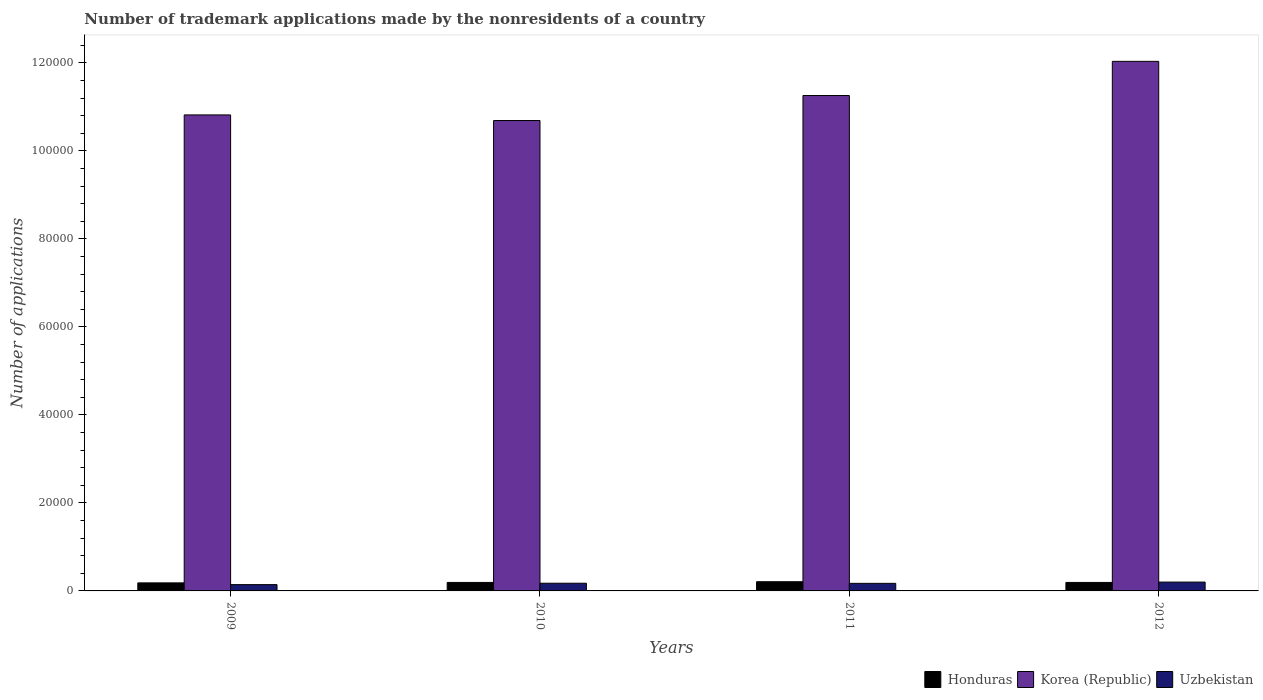Are the number of bars per tick equal to the number of legend labels?
Make the answer very short. Yes. How many bars are there on the 3rd tick from the left?
Provide a short and direct response. 3. How many bars are there on the 2nd tick from the right?
Provide a succinct answer. 3. What is the number of trademark applications made by the nonresidents in Uzbekistan in 2009?
Your answer should be compact. 1431. Across all years, what is the maximum number of trademark applications made by the nonresidents in Honduras?
Your response must be concise. 2089. Across all years, what is the minimum number of trademark applications made by the nonresidents in Korea (Republic)?
Your response must be concise. 1.07e+05. What is the total number of trademark applications made by the nonresidents in Uzbekistan in the graph?
Offer a terse response. 6908. What is the difference between the number of trademark applications made by the nonresidents in Uzbekistan in 2010 and the number of trademark applications made by the nonresidents in Honduras in 2009?
Offer a very short reply. -78. What is the average number of trademark applications made by the nonresidents in Honduras per year?
Your answer should be compact. 1944. In the year 2010, what is the difference between the number of trademark applications made by the nonresidents in Honduras and number of trademark applications made by the nonresidents in Uzbekistan?
Provide a succinct answer. 180. In how many years, is the number of trademark applications made by the nonresidents in Korea (Republic) greater than 60000?
Your response must be concise. 4. What is the ratio of the number of trademark applications made by the nonresidents in Korea (Republic) in 2009 to that in 2011?
Provide a short and direct response. 0.96. Is the number of trademark applications made by the nonresidents in Honduras in 2009 less than that in 2010?
Offer a terse response. Yes. What is the difference between the highest and the second highest number of trademark applications made by the nonresidents in Uzbekistan?
Give a very brief answer. 257. What is the difference between the highest and the lowest number of trademark applications made by the nonresidents in Uzbekistan?
Offer a very short reply. 576. In how many years, is the number of trademark applications made by the nonresidents in Honduras greater than the average number of trademark applications made by the nonresidents in Honduras taken over all years?
Make the answer very short. 1. What does the 3rd bar from the left in 2010 represents?
Your response must be concise. Uzbekistan. What does the 1st bar from the right in 2009 represents?
Keep it short and to the point. Uzbekistan. Is it the case that in every year, the sum of the number of trademark applications made by the nonresidents in Uzbekistan and number of trademark applications made by the nonresidents in Honduras is greater than the number of trademark applications made by the nonresidents in Korea (Republic)?
Offer a terse response. No. How many bars are there?
Provide a succinct answer. 12. How many years are there in the graph?
Your answer should be compact. 4. What is the difference between two consecutive major ticks on the Y-axis?
Give a very brief answer. 2.00e+04. Are the values on the major ticks of Y-axis written in scientific E-notation?
Your response must be concise. No. Does the graph contain any zero values?
Ensure brevity in your answer.  No. How many legend labels are there?
Offer a terse response. 3. How are the legend labels stacked?
Keep it short and to the point. Horizontal. What is the title of the graph?
Your answer should be very brief. Number of trademark applications made by the nonresidents of a country. Does "Oman" appear as one of the legend labels in the graph?
Offer a terse response. No. What is the label or title of the Y-axis?
Your answer should be very brief. Number of applications. What is the Number of applications of Honduras in 2009?
Make the answer very short. 1828. What is the Number of applications in Korea (Republic) in 2009?
Give a very brief answer. 1.08e+05. What is the Number of applications in Uzbekistan in 2009?
Provide a succinct answer. 1431. What is the Number of applications of Honduras in 2010?
Your answer should be compact. 1930. What is the Number of applications in Korea (Republic) in 2010?
Make the answer very short. 1.07e+05. What is the Number of applications in Uzbekistan in 2010?
Make the answer very short. 1750. What is the Number of applications of Honduras in 2011?
Make the answer very short. 2089. What is the Number of applications of Korea (Republic) in 2011?
Keep it short and to the point. 1.13e+05. What is the Number of applications in Uzbekistan in 2011?
Your answer should be compact. 1720. What is the Number of applications in Honduras in 2012?
Provide a succinct answer. 1929. What is the Number of applications in Korea (Republic) in 2012?
Provide a succinct answer. 1.20e+05. What is the Number of applications of Uzbekistan in 2012?
Keep it short and to the point. 2007. Across all years, what is the maximum Number of applications of Honduras?
Give a very brief answer. 2089. Across all years, what is the maximum Number of applications in Korea (Republic)?
Offer a very short reply. 1.20e+05. Across all years, what is the maximum Number of applications in Uzbekistan?
Offer a terse response. 2007. Across all years, what is the minimum Number of applications of Honduras?
Your response must be concise. 1828. Across all years, what is the minimum Number of applications of Korea (Republic)?
Make the answer very short. 1.07e+05. Across all years, what is the minimum Number of applications in Uzbekistan?
Provide a succinct answer. 1431. What is the total Number of applications in Honduras in the graph?
Give a very brief answer. 7776. What is the total Number of applications of Korea (Republic) in the graph?
Provide a succinct answer. 4.48e+05. What is the total Number of applications of Uzbekistan in the graph?
Ensure brevity in your answer.  6908. What is the difference between the Number of applications of Honduras in 2009 and that in 2010?
Ensure brevity in your answer.  -102. What is the difference between the Number of applications in Korea (Republic) in 2009 and that in 2010?
Your response must be concise. 1274. What is the difference between the Number of applications of Uzbekistan in 2009 and that in 2010?
Ensure brevity in your answer.  -319. What is the difference between the Number of applications of Honduras in 2009 and that in 2011?
Make the answer very short. -261. What is the difference between the Number of applications of Korea (Republic) in 2009 and that in 2011?
Provide a short and direct response. -4406. What is the difference between the Number of applications of Uzbekistan in 2009 and that in 2011?
Keep it short and to the point. -289. What is the difference between the Number of applications in Honduras in 2009 and that in 2012?
Offer a very short reply. -101. What is the difference between the Number of applications of Korea (Republic) in 2009 and that in 2012?
Make the answer very short. -1.22e+04. What is the difference between the Number of applications of Uzbekistan in 2009 and that in 2012?
Your answer should be compact. -576. What is the difference between the Number of applications in Honduras in 2010 and that in 2011?
Your answer should be compact. -159. What is the difference between the Number of applications in Korea (Republic) in 2010 and that in 2011?
Ensure brevity in your answer.  -5680. What is the difference between the Number of applications of Uzbekistan in 2010 and that in 2011?
Make the answer very short. 30. What is the difference between the Number of applications of Honduras in 2010 and that in 2012?
Make the answer very short. 1. What is the difference between the Number of applications of Korea (Republic) in 2010 and that in 2012?
Offer a terse response. -1.34e+04. What is the difference between the Number of applications of Uzbekistan in 2010 and that in 2012?
Offer a terse response. -257. What is the difference between the Number of applications in Honduras in 2011 and that in 2012?
Your answer should be compact. 160. What is the difference between the Number of applications of Korea (Republic) in 2011 and that in 2012?
Ensure brevity in your answer.  -7765. What is the difference between the Number of applications in Uzbekistan in 2011 and that in 2012?
Keep it short and to the point. -287. What is the difference between the Number of applications of Honduras in 2009 and the Number of applications of Korea (Republic) in 2010?
Your answer should be compact. -1.05e+05. What is the difference between the Number of applications of Honduras in 2009 and the Number of applications of Uzbekistan in 2010?
Your response must be concise. 78. What is the difference between the Number of applications in Korea (Republic) in 2009 and the Number of applications in Uzbekistan in 2010?
Provide a short and direct response. 1.06e+05. What is the difference between the Number of applications in Honduras in 2009 and the Number of applications in Korea (Republic) in 2011?
Offer a terse response. -1.11e+05. What is the difference between the Number of applications of Honduras in 2009 and the Number of applications of Uzbekistan in 2011?
Your answer should be compact. 108. What is the difference between the Number of applications of Korea (Republic) in 2009 and the Number of applications of Uzbekistan in 2011?
Offer a terse response. 1.06e+05. What is the difference between the Number of applications in Honduras in 2009 and the Number of applications in Korea (Republic) in 2012?
Keep it short and to the point. -1.19e+05. What is the difference between the Number of applications in Honduras in 2009 and the Number of applications in Uzbekistan in 2012?
Give a very brief answer. -179. What is the difference between the Number of applications in Korea (Republic) in 2009 and the Number of applications in Uzbekistan in 2012?
Offer a terse response. 1.06e+05. What is the difference between the Number of applications in Honduras in 2010 and the Number of applications in Korea (Republic) in 2011?
Give a very brief answer. -1.11e+05. What is the difference between the Number of applications in Honduras in 2010 and the Number of applications in Uzbekistan in 2011?
Your response must be concise. 210. What is the difference between the Number of applications of Korea (Republic) in 2010 and the Number of applications of Uzbekistan in 2011?
Your response must be concise. 1.05e+05. What is the difference between the Number of applications of Honduras in 2010 and the Number of applications of Korea (Republic) in 2012?
Ensure brevity in your answer.  -1.18e+05. What is the difference between the Number of applications of Honduras in 2010 and the Number of applications of Uzbekistan in 2012?
Provide a succinct answer. -77. What is the difference between the Number of applications in Korea (Republic) in 2010 and the Number of applications in Uzbekistan in 2012?
Provide a short and direct response. 1.05e+05. What is the difference between the Number of applications in Honduras in 2011 and the Number of applications in Korea (Republic) in 2012?
Provide a succinct answer. -1.18e+05. What is the difference between the Number of applications of Korea (Republic) in 2011 and the Number of applications of Uzbekistan in 2012?
Make the answer very short. 1.11e+05. What is the average Number of applications of Honduras per year?
Your response must be concise. 1944. What is the average Number of applications in Korea (Republic) per year?
Provide a succinct answer. 1.12e+05. What is the average Number of applications of Uzbekistan per year?
Your answer should be compact. 1727. In the year 2009, what is the difference between the Number of applications in Honduras and Number of applications in Korea (Republic)?
Make the answer very short. -1.06e+05. In the year 2009, what is the difference between the Number of applications in Honduras and Number of applications in Uzbekistan?
Your response must be concise. 397. In the year 2009, what is the difference between the Number of applications of Korea (Republic) and Number of applications of Uzbekistan?
Make the answer very short. 1.07e+05. In the year 2010, what is the difference between the Number of applications of Honduras and Number of applications of Korea (Republic)?
Offer a terse response. -1.05e+05. In the year 2010, what is the difference between the Number of applications of Honduras and Number of applications of Uzbekistan?
Keep it short and to the point. 180. In the year 2010, what is the difference between the Number of applications of Korea (Republic) and Number of applications of Uzbekistan?
Your answer should be compact. 1.05e+05. In the year 2011, what is the difference between the Number of applications in Honduras and Number of applications in Korea (Republic)?
Your answer should be very brief. -1.10e+05. In the year 2011, what is the difference between the Number of applications of Honduras and Number of applications of Uzbekistan?
Your answer should be very brief. 369. In the year 2011, what is the difference between the Number of applications of Korea (Republic) and Number of applications of Uzbekistan?
Offer a terse response. 1.11e+05. In the year 2012, what is the difference between the Number of applications in Honduras and Number of applications in Korea (Republic)?
Provide a succinct answer. -1.18e+05. In the year 2012, what is the difference between the Number of applications of Honduras and Number of applications of Uzbekistan?
Give a very brief answer. -78. In the year 2012, what is the difference between the Number of applications in Korea (Republic) and Number of applications in Uzbekistan?
Provide a succinct answer. 1.18e+05. What is the ratio of the Number of applications of Honduras in 2009 to that in 2010?
Offer a very short reply. 0.95. What is the ratio of the Number of applications in Korea (Republic) in 2009 to that in 2010?
Offer a terse response. 1.01. What is the ratio of the Number of applications of Uzbekistan in 2009 to that in 2010?
Give a very brief answer. 0.82. What is the ratio of the Number of applications in Honduras in 2009 to that in 2011?
Your answer should be compact. 0.88. What is the ratio of the Number of applications of Korea (Republic) in 2009 to that in 2011?
Offer a terse response. 0.96. What is the ratio of the Number of applications in Uzbekistan in 2009 to that in 2011?
Give a very brief answer. 0.83. What is the ratio of the Number of applications of Honduras in 2009 to that in 2012?
Your answer should be very brief. 0.95. What is the ratio of the Number of applications in Korea (Republic) in 2009 to that in 2012?
Provide a succinct answer. 0.9. What is the ratio of the Number of applications of Uzbekistan in 2009 to that in 2012?
Give a very brief answer. 0.71. What is the ratio of the Number of applications of Honduras in 2010 to that in 2011?
Make the answer very short. 0.92. What is the ratio of the Number of applications in Korea (Republic) in 2010 to that in 2011?
Provide a succinct answer. 0.95. What is the ratio of the Number of applications in Uzbekistan in 2010 to that in 2011?
Provide a succinct answer. 1.02. What is the ratio of the Number of applications in Honduras in 2010 to that in 2012?
Make the answer very short. 1. What is the ratio of the Number of applications in Korea (Republic) in 2010 to that in 2012?
Offer a very short reply. 0.89. What is the ratio of the Number of applications in Uzbekistan in 2010 to that in 2012?
Your answer should be very brief. 0.87. What is the ratio of the Number of applications in Honduras in 2011 to that in 2012?
Your response must be concise. 1.08. What is the ratio of the Number of applications in Korea (Republic) in 2011 to that in 2012?
Your response must be concise. 0.94. What is the ratio of the Number of applications in Uzbekistan in 2011 to that in 2012?
Offer a terse response. 0.86. What is the difference between the highest and the second highest Number of applications of Honduras?
Offer a terse response. 159. What is the difference between the highest and the second highest Number of applications in Korea (Republic)?
Keep it short and to the point. 7765. What is the difference between the highest and the second highest Number of applications of Uzbekistan?
Make the answer very short. 257. What is the difference between the highest and the lowest Number of applications of Honduras?
Give a very brief answer. 261. What is the difference between the highest and the lowest Number of applications in Korea (Republic)?
Offer a very short reply. 1.34e+04. What is the difference between the highest and the lowest Number of applications of Uzbekistan?
Make the answer very short. 576. 